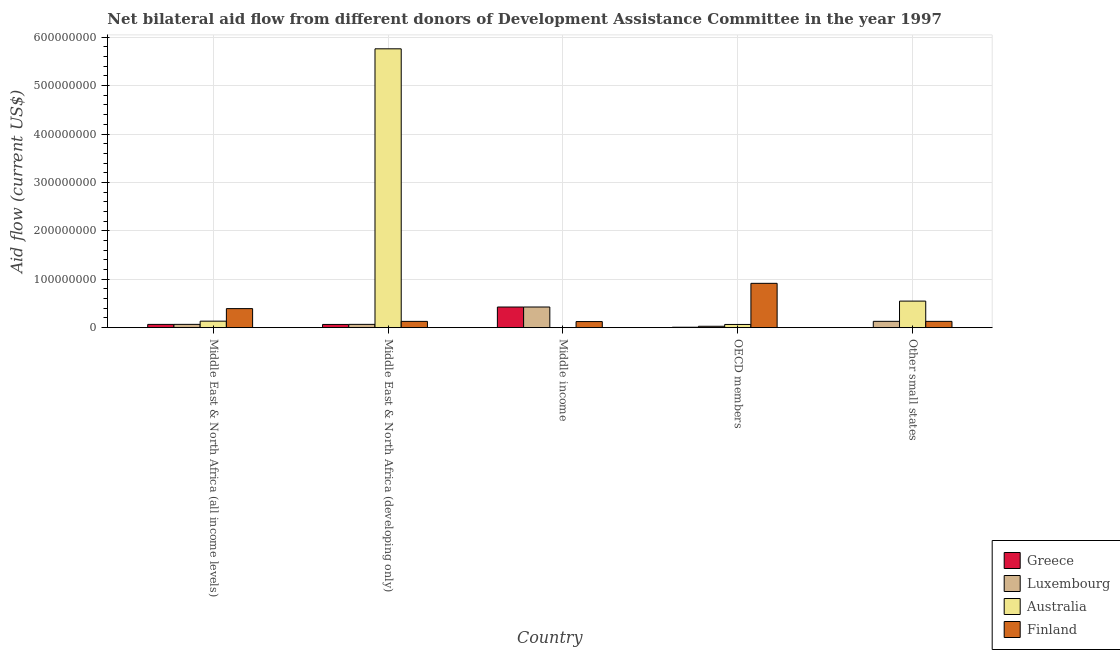How many different coloured bars are there?
Provide a succinct answer. 4. Are the number of bars per tick equal to the number of legend labels?
Keep it short and to the point. Yes. Are the number of bars on each tick of the X-axis equal?
Keep it short and to the point. Yes. How many bars are there on the 4th tick from the right?
Offer a terse response. 4. What is the label of the 5th group of bars from the left?
Your answer should be very brief. Other small states. What is the amount of aid given by finland in Other small states?
Make the answer very short. 1.30e+07. Across all countries, what is the maximum amount of aid given by greece?
Keep it short and to the point. 4.26e+07. Across all countries, what is the minimum amount of aid given by luxembourg?
Offer a terse response. 2.88e+06. In which country was the amount of aid given by finland maximum?
Make the answer very short. OECD members. In which country was the amount of aid given by luxembourg minimum?
Your answer should be compact. OECD members. What is the total amount of aid given by luxembourg in the graph?
Make the answer very short. 7.22e+07. What is the difference between the amount of aid given by australia in OECD members and that in Other small states?
Offer a very short reply. -4.82e+07. What is the difference between the amount of aid given by australia in OECD members and the amount of aid given by luxembourg in Middle East & North Africa (all income levels)?
Make the answer very short. -1.80e+05. What is the average amount of aid given by greece per country?
Your answer should be very brief. 1.14e+07. What is the difference between the amount of aid given by luxembourg and amount of aid given by greece in Other small states?
Provide a succinct answer. 1.30e+07. What is the ratio of the amount of aid given by finland in OECD members to that in Other small states?
Your answer should be very brief. 7.04. Is the amount of aid given by australia in Middle East & North Africa (developing only) less than that in OECD members?
Your answer should be very brief. No. What is the difference between the highest and the second highest amount of aid given by australia?
Your answer should be compact. 5.21e+08. What is the difference between the highest and the lowest amount of aid given by finland?
Give a very brief answer. 7.90e+07. Is the sum of the amount of aid given by greece in Middle East & North Africa (all income levels) and Other small states greater than the maximum amount of aid given by australia across all countries?
Provide a succinct answer. No. What does the 1st bar from the right in Middle East & North Africa (developing only) represents?
Provide a succinct answer. Finland. How many bars are there?
Give a very brief answer. 20. How many countries are there in the graph?
Provide a short and direct response. 5. What is the difference between two consecutive major ticks on the Y-axis?
Your response must be concise. 1.00e+08. Are the values on the major ticks of Y-axis written in scientific E-notation?
Provide a short and direct response. No. Does the graph contain any zero values?
Provide a succinct answer. No. Does the graph contain grids?
Provide a short and direct response. Yes. How many legend labels are there?
Offer a terse response. 4. How are the legend labels stacked?
Provide a short and direct response. Vertical. What is the title of the graph?
Your answer should be very brief. Net bilateral aid flow from different donors of Development Assistance Committee in the year 1997. Does "Fiscal policy" appear as one of the legend labels in the graph?
Your answer should be very brief. No. What is the Aid flow (current US$) in Greece in Middle East & North Africa (all income levels)?
Your answer should be compact. 6.76e+06. What is the Aid flow (current US$) of Luxembourg in Middle East & North Africa (all income levels)?
Your response must be concise. 6.80e+06. What is the Aid flow (current US$) in Australia in Middle East & North Africa (all income levels)?
Provide a short and direct response. 1.34e+07. What is the Aid flow (current US$) in Finland in Middle East & North Africa (all income levels)?
Provide a short and direct response. 3.94e+07. What is the Aid flow (current US$) of Greece in Middle East & North Africa (developing only)?
Ensure brevity in your answer.  6.66e+06. What is the Aid flow (current US$) in Luxembourg in Middle East & North Africa (developing only)?
Keep it short and to the point. 6.80e+06. What is the Aid flow (current US$) in Australia in Middle East & North Africa (developing only)?
Offer a terse response. 5.76e+08. What is the Aid flow (current US$) in Finland in Middle East & North Africa (developing only)?
Your answer should be compact. 1.30e+07. What is the Aid flow (current US$) in Greece in Middle income?
Offer a very short reply. 4.26e+07. What is the Aid flow (current US$) in Luxembourg in Middle income?
Your answer should be compact. 4.27e+07. What is the Aid flow (current US$) in Australia in Middle income?
Your answer should be compact. 2.40e+05. What is the Aid flow (current US$) of Finland in Middle income?
Your answer should be compact. 1.26e+07. What is the Aid flow (current US$) in Luxembourg in OECD members?
Ensure brevity in your answer.  2.88e+06. What is the Aid flow (current US$) of Australia in OECD members?
Offer a terse response. 6.62e+06. What is the Aid flow (current US$) of Finland in OECD members?
Offer a very short reply. 9.16e+07. What is the Aid flow (current US$) in Greece in Other small states?
Offer a terse response. 1.10e+05. What is the Aid flow (current US$) of Luxembourg in Other small states?
Provide a succinct answer. 1.31e+07. What is the Aid flow (current US$) in Australia in Other small states?
Provide a succinct answer. 5.49e+07. What is the Aid flow (current US$) of Finland in Other small states?
Make the answer very short. 1.30e+07. Across all countries, what is the maximum Aid flow (current US$) in Greece?
Keep it short and to the point. 4.26e+07. Across all countries, what is the maximum Aid flow (current US$) in Luxembourg?
Ensure brevity in your answer.  4.27e+07. Across all countries, what is the maximum Aid flow (current US$) of Australia?
Provide a short and direct response. 5.76e+08. Across all countries, what is the maximum Aid flow (current US$) in Finland?
Offer a terse response. 9.16e+07. Across all countries, what is the minimum Aid flow (current US$) of Greece?
Give a very brief answer. 1.10e+05. Across all countries, what is the minimum Aid flow (current US$) in Luxembourg?
Provide a short and direct response. 2.88e+06. Across all countries, what is the minimum Aid flow (current US$) in Australia?
Your answer should be very brief. 2.40e+05. Across all countries, what is the minimum Aid flow (current US$) in Finland?
Your answer should be compact. 1.26e+07. What is the total Aid flow (current US$) of Greece in the graph?
Give a very brief answer. 5.71e+07. What is the total Aid flow (current US$) of Luxembourg in the graph?
Ensure brevity in your answer.  7.22e+07. What is the total Aid flow (current US$) in Australia in the graph?
Make the answer very short. 6.51e+08. What is the total Aid flow (current US$) in Finland in the graph?
Keep it short and to the point. 1.69e+08. What is the difference between the Aid flow (current US$) of Luxembourg in Middle East & North Africa (all income levels) and that in Middle East & North Africa (developing only)?
Your answer should be compact. 0. What is the difference between the Aid flow (current US$) of Australia in Middle East & North Africa (all income levels) and that in Middle East & North Africa (developing only)?
Provide a succinct answer. -5.63e+08. What is the difference between the Aid flow (current US$) of Finland in Middle East & North Africa (all income levels) and that in Middle East & North Africa (developing only)?
Provide a short and direct response. 2.64e+07. What is the difference between the Aid flow (current US$) in Greece in Middle East & North Africa (all income levels) and that in Middle income?
Offer a terse response. -3.59e+07. What is the difference between the Aid flow (current US$) in Luxembourg in Middle East & North Africa (all income levels) and that in Middle income?
Your answer should be very brief. -3.59e+07. What is the difference between the Aid flow (current US$) in Australia in Middle East & North Africa (all income levels) and that in Middle income?
Give a very brief answer. 1.32e+07. What is the difference between the Aid flow (current US$) in Finland in Middle East & North Africa (all income levels) and that in Middle income?
Offer a very short reply. 2.68e+07. What is the difference between the Aid flow (current US$) in Greece in Middle East & North Africa (all income levels) and that in OECD members?
Provide a short and direct response. 5.86e+06. What is the difference between the Aid flow (current US$) of Luxembourg in Middle East & North Africa (all income levels) and that in OECD members?
Make the answer very short. 3.92e+06. What is the difference between the Aid flow (current US$) in Australia in Middle East & North Africa (all income levels) and that in OECD members?
Make the answer very short. 6.80e+06. What is the difference between the Aid flow (current US$) of Finland in Middle East & North Africa (all income levels) and that in OECD members?
Ensure brevity in your answer.  -5.22e+07. What is the difference between the Aid flow (current US$) in Greece in Middle East & North Africa (all income levels) and that in Other small states?
Your response must be concise. 6.65e+06. What is the difference between the Aid flow (current US$) of Luxembourg in Middle East & North Africa (all income levels) and that in Other small states?
Ensure brevity in your answer.  -6.26e+06. What is the difference between the Aid flow (current US$) in Australia in Middle East & North Africa (all income levels) and that in Other small states?
Offer a very short reply. -4.14e+07. What is the difference between the Aid flow (current US$) of Finland in Middle East & North Africa (all income levels) and that in Other small states?
Your response must be concise. 2.64e+07. What is the difference between the Aid flow (current US$) in Greece in Middle East & North Africa (developing only) and that in Middle income?
Make the answer very short. -3.60e+07. What is the difference between the Aid flow (current US$) in Luxembourg in Middle East & North Africa (developing only) and that in Middle income?
Provide a succinct answer. -3.59e+07. What is the difference between the Aid flow (current US$) of Australia in Middle East & North Africa (developing only) and that in Middle income?
Make the answer very short. 5.76e+08. What is the difference between the Aid flow (current US$) in Greece in Middle East & North Africa (developing only) and that in OECD members?
Offer a very short reply. 5.76e+06. What is the difference between the Aid flow (current US$) of Luxembourg in Middle East & North Africa (developing only) and that in OECD members?
Offer a very short reply. 3.92e+06. What is the difference between the Aid flow (current US$) in Australia in Middle East & North Africa (developing only) and that in OECD members?
Provide a succinct answer. 5.69e+08. What is the difference between the Aid flow (current US$) in Finland in Middle East & North Africa (developing only) and that in OECD members?
Your response must be concise. -7.86e+07. What is the difference between the Aid flow (current US$) of Greece in Middle East & North Africa (developing only) and that in Other small states?
Make the answer very short. 6.55e+06. What is the difference between the Aid flow (current US$) in Luxembourg in Middle East & North Africa (developing only) and that in Other small states?
Offer a terse response. -6.26e+06. What is the difference between the Aid flow (current US$) in Australia in Middle East & North Africa (developing only) and that in Other small states?
Your answer should be compact. 5.21e+08. What is the difference between the Aid flow (current US$) of Finland in Middle East & North Africa (developing only) and that in Other small states?
Your answer should be very brief. -3.00e+04. What is the difference between the Aid flow (current US$) in Greece in Middle income and that in OECD members?
Provide a short and direct response. 4.17e+07. What is the difference between the Aid flow (current US$) of Luxembourg in Middle income and that in OECD members?
Offer a terse response. 3.98e+07. What is the difference between the Aid flow (current US$) in Australia in Middle income and that in OECD members?
Provide a succinct answer. -6.38e+06. What is the difference between the Aid flow (current US$) in Finland in Middle income and that in OECD members?
Provide a short and direct response. -7.90e+07. What is the difference between the Aid flow (current US$) in Greece in Middle income and that in Other small states?
Give a very brief answer. 4.25e+07. What is the difference between the Aid flow (current US$) of Luxembourg in Middle income and that in Other small states?
Offer a terse response. 2.96e+07. What is the difference between the Aid flow (current US$) of Australia in Middle income and that in Other small states?
Give a very brief answer. -5.46e+07. What is the difference between the Aid flow (current US$) of Finland in Middle income and that in Other small states?
Provide a succinct answer. -4.20e+05. What is the difference between the Aid flow (current US$) in Greece in OECD members and that in Other small states?
Keep it short and to the point. 7.90e+05. What is the difference between the Aid flow (current US$) in Luxembourg in OECD members and that in Other small states?
Offer a terse response. -1.02e+07. What is the difference between the Aid flow (current US$) of Australia in OECD members and that in Other small states?
Your response must be concise. -4.82e+07. What is the difference between the Aid flow (current US$) in Finland in OECD members and that in Other small states?
Your answer should be very brief. 7.86e+07. What is the difference between the Aid flow (current US$) of Greece in Middle East & North Africa (all income levels) and the Aid flow (current US$) of Luxembourg in Middle East & North Africa (developing only)?
Offer a terse response. -4.00e+04. What is the difference between the Aid flow (current US$) in Greece in Middle East & North Africa (all income levels) and the Aid flow (current US$) in Australia in Middle East & North Africa (developing only)?
Your answer should be very brief. -5.69e+08. What is the difference between the Aid flow (current US$) of Greece in Middle East & North Africa (all income levels) and the Aid flow (current US$) of Finland in Middle East & North Africa (developing only)?
Make the answer very short. -6.21e+06. What is the difference between the Aid flow (current US$) of Luxembourg in Middle East & North Africa (all income levels) and the Aid flow (current US$) of Australia in Middle East & North Africa (developing only)?
Provide a short and direct response. -5.69e+08. What is the difference between the Aid flow (current US$) of Luxembourg in Middle East & North Africa (all income levels) and the Aid flow (current US$) of Finland in Middle East & North Africa (developing only)?
Your answer should be compact. -6.17e+06. What is the difference between the Aid flow (current US$) of Greece in Middle East & North Africa (all income levels) and the Aid flow (current US$) of Luxembourg in Middle income?
Provide a succinct answer. -3.59e+07. What is the difference between the Aid flow (current US$) in Greece in Middle East & North Africa (all income levels) and the Aid flow (current US$) in Australia in Middle income?
Offer a terse response. 6.52e+06. What is the difference between the Aid flow (current US$) in Greece in Middle East & North Africa (all income levels) and the Aid flow (current US$) in Finland in Middle income?
Your answer should be very brief. -5.82e+06. What is the difference between the Aid flow (current US$) in Luxembourg in Middle East & North Africa (all income levels) and the Aid flow (current US$) in Australia in Middle income?
Offer a terse response. 6.56e+06. What is the difference between the Aid flow (current US$) of Luxembourg in Middle East & North Africa (all income levels) and the Aid flow (current US$) of Finland in Middle income?
Offer a very short reply. -5.78e+06. What is the difference between the Aid flow (current US$) in Australia in Middle East & North Africa (all income levels) and the Aid flow (current US$) in Finland in Middle income?
Provide a short and direct response. 8.40e+05. What is the difference between the Aid flow (current US$) of Greece in Middle East & North Africa (all income levels) and the Aid flow (current US$) of Luxembourg in OECD members?
Give a very brief answer. 3.88e+06. What is the difference between the Aid flow (current US$) in Greece in Middle East & North Africa (all income levels) and the Aid flow (current US$) in Finland in OECD members?
Offer a very short reply. -8.48e+07. What is the difference between the Aid flow (current US$) of Luxembourg in Middle East & North Africa (all income levels) and the Aid flow (current US$) of Australia in OECD members?
Make the answer very short. 1.80e+05. What is the difference between the Aid flow (current US$) in Luxembourg in Middle East & North Africa (all income levels) and the Aid flow (current US$) in Finland in OECD members?
Provide a succinct answer. -8.48e+07. What is the difference between the Aid flow (current US$) of Australia in Middle East & North Africa (all income levels) and the Aid flow (current US$) of Finland in OECD members?
Ensure brevity in your answer.  -7.82e+07. What is the difference between the Aid flow (current US$) in Greece in Middle East & North Africa (all income levels) and the Aid flow (current US$) in Luxembourg in Other small states?
Your answer should be compact. -6.30e+06. What is the difference between the Aid flow (current US$) in Greece in Middle East & North Africa (all income levels) and the Aid flow (current US$) in Australia in Other small states?
Keep it short and to the point. -4.81e+07. What is the difference between the Aid flow (current US$) of Greece in Middle East & North Africa (all income levels) and the Aid flow (current US$) of Finland in Other small states?
Your answer should be very brief. -6.24e+06. What is the difference between the Aid flow (current US$) of Luxembourg in Middle East & North Africa (all income levels) and the Aid flow (current US$) of Australia in Other small states?
Ensure brevity in your answer.  -4.81e+07. What is the difference between the Aid flow (current US$) in Luxembourg in Middle East & North Africa (all income levels) and the Aid flow (current US$) in Finland in Other small states?
Offer a very short reply. -6.20e+06. What is the difference between the Aid flow (current US$) of Greece in Middle East & North Africa (developing only) and the Aid flow (current US$) of Luxembourg in Middle income?
Provide a succinct answer. -3.60e+07. What is the difference between the Aid flow (current US$) of Greece in Middle East & North Africa (developing only) and the Aid flow (current US$) of Australia in Middle income?
Offer a very short reply. 6.42e+06. What is the difference between the Aid flow (current US$) of Greece in Middle East & North Africa (developing only) and the Aid flow (current US$) of Finland in Middle income?
Provide a succinct answer. -5.92e+06. What is the difference between the Aid flow (current US$) in Luxembourg in Middle East & North Africa (developing only) and the Aid flow (current US$) in Australia in Middle income?
Keep it short and to the point. 6.56e+06. What is the difference between the Aid flow (current US$) of Luxembourg in Middle East & North Africa (developing only) and the Aid flow (current US$) of Finland in Middle income?
Ensure brevity in your answer.  -5.78e+06. What is the difference between the Aid flow (current US$) of Australia in Middle East & North Africa (developing only) and the Aid flow (current US$) of Finland in Middle income?
Provide a succinct answer. 5.63e+08. What is the difference between the Aid flow (current US$) in Greece in Middle East & North Africa (developing only) and the Aid flow (current US$) in Luxembourg in OECD members?
Provide a short and direct response. 3.78e+06. What is the difference between the Aid flow (current US$) of Greece in Middle East & North Africa (developing only) and the Aid flow (current US$) of Australia in OECD members?
Offer a terse response. 4.00e+04. What is the difference between the Aid flow (current US$) in Greece in Middle East & North Africa (developing only) and the Aid flow (current US$) in Finland in OECD members?
Offer a very short reply. -8.49e+07. What is the difference between the Aid flow (current US$) of Luxembourg in Middle East & North Africa (developing only) and the Aid flow (current US$) of Australia in OECD members?
Offer a very short reply. 1.80e+05. What is the difference between the Aid flow (current US$) in Luxembourg in Middle East & North Africa (developing only) and the Aid flow (current US$) in Finland in OECD members?
Ensure brevity in your answer.  -8.48e+07. What is the difference between the Aid flow (current US$) of Australia in Middle East & North Africa (developing only) and the Aid flow (current US$) of Finland in OECD members?
Your response must be concise. 4.84e+08. What is the difference between the Aid flow (current US$) in Greece in Middle East & North Africa (developing only) and the Aid flow (current US$) in Luxembourg in Other small states?
Provide a short and direct response. -6.40e+06. What is the difference between the Aid flow (current US$) in Greece in Middle East & North Africa (developing only) and the Aid flow (current US$) in Australia in Other small states?
Your answer should be very brief. -4.82e+07. What is the difference between the Aid flow (current US$) of Greece in Middle East & North Africa (developing only) and the Aid flow (current US$) of Finland in Other small states?
Provide a succinct answer. -6.34e+06. What is the difference between the Aid flow (current US$) in Luxembourg in Middle East & North Africa (developing only) and the Aid flow (current US$) in Australia in Other small states?
Your answer should be very brief. -4.81e+07. What is the difference between the Aid flow (current US$) of Luxembourg in Middle East & North Africa (developing only) and the Aid flow (current US$) of Finland in Other small states?
Your answer should be compact. -6.20e+06. What is the difference between the Aid flow (current US$) of Australia in Middle East & North Africa (developing only) and the Aid flow (current US$) of Finland in Other small states?
Provide a short and direct response. 5.63e+08. What is the difference between the Aid flow (current US$) in Greece in Middle income and the Aid flow (current US$) in Luxembourg in OECD members?
Keep it short and to the point. 3.98e+07. What is the difference between the Aid flow (current US$) in Greece in Middle income and the Aid flow (current US$) in Australia in OECD members?
Provide a short and direct response. 3.60e+07. What is the difference between the Aid flow (current US$) in Greece in Middle income and the Aid flow (current US$) in Finland in OECD members?
Keep it short and to the point. -4.89e+07. What is the difference between the Aid flow (current US$) in Luxembourg in Middle income and the Aid flow (current US$) in Australia in OECD members?
Offer a very short reply. 3.60e+07. What is the difference between the Aid flow (current US$) of Luxembourg in Middle income and the Aid flow (current US$) of Finland in OECD members?
Provide a succinct answer. -4.89e+07. What is the difference between the Aid flow (current US$) in Australia in Middle income and the Aid flow (current US$) in Finland in OECD members?
Give a very brief answer. -9.13e+07. What is the difference between the Aid flow (current US$) of Greece in Middle income and the Aid flow (current US$) of Luxembourg in Other small states?
Provide a succinct answer. 2.96e+07. What is the difference between the Aid flow (current US$) of Greece in Middle income and the Aid flow (current US$) of Australia in Other small states?
Ensure brevity in your answer.  -1.22e+07. What is the difference between the Aid flow (current US$) in Greece in Middle income and the Aid flow (current US$) in Finland in Other small states?
Keep it short and to the point. 2.96e+07. What is the difference between the Aid flow (current US$) of Luxembourg in Middle income and the Aid flow (current US$) of Australia in Other small states?
Your answer should be compact. -1.22e+07. What is the difference between the Aid flow (current US$) of Luxembourg in Middle income and the Aid flow (current US$) of Finland in Other small states?
Provide a succinct answer. 2.97e+07. What is the difference between the Aid flow (current US$) in Australia in Middle income and the Aid flow (current US$) in Finland in Other small states?
Keep it short and to the point. -1.28e+07. What is the difference between the Aid flow (current US$) in Greece in OECD members and the Aid flow (current US$) in Luxembourg in Other small states?
Your answer should be very brief. -1.22e+07. What is the difference between the Aid flow (current US$) in Greece in OECD members and the Aid flow (current US$) in Australia in Other small states?
Offer a very short reply. -5.40e+07. What is the difference between the Aid flow (current US$) of Greece in OECD members and the Aid flow (current US$) of Finland in Other small states?
Offer a terse response. -1.21e+07. What is the difference between the Aid flow (current US$) in Luxembourg in OECD members and the Aid flow (current US$) in Australia in Other small states?
Offer a very short reply. -5.20e+07. What is the difference between the Aid flow (current US$) in Luxembourg in OECD members and the Aid flow (current US$) in Finland in Other small states?
Offer a terse response. -1.01e+07. What is the difference between the Aid flow (current US$) of Australia in OECD members and the Aid flow (current US$) of Finland in Other small states?
Your answer should be very brief. -6.38e+06. What is the average Aid flow (current US$) in Greece per country?
Your response must be concise. 1.14e+07. What is the average Aid flow (current US$) of Luxembourg per country?
Offer a very short reply. 1.44e+07. What is the average Aid flow (current US$) in Australia per country?
Keep it short and to the point. 1.30e+08. What is the average Aid flow (current US$) in Finland per country?
Provide a short and direct response. 3.39e+07. What is the difference between the Aid flow (current US$) in Greece and Aid flow (current US$) in Australia in Middle East & North Africa (all income levels)?
Give a very brief answer. -6.66e+06. What is the difference between the Aid flow (current US$) in Greece and Aid flow (current US$) in Finland in Middle East & North Africa (all income levels)?
Offer a terse response. -3.26e+07. What is the difference between the Aid flow (current US$) of Luxembourg and Aid flow (current US$) of Australia in Middle East & North Africa (all income levels)?
Keep it short and to the point. -6.62e+06. What is the difference between the Aid flow (current US$) of Luxembourg and Aid flow (current US$) of Finland in Middle East & North Africa (all income levels)?
Give a very brief answer. -3.26e+07. What is the difference between the Aid flow (current US$) in Australia and Aid flow (current US$) in Finland in Middle East & North Africa (all income levels)?
Give a very brief answer. -2.59e+07. What is the difference between the Aid flow (current US$) of Greece and Aid flow (current US$) of Australia in Middle East & North Africa (developing only)?
Offer a very short reply. -5.69e+08. What is the difference between the Aid flow (current US$) in Greece and Aid flow (current US$) in Finland in Middle East & North Africa (developing only)?
Your answer should be compact. -6.31e+06. What is the difference between the Aid flow (current US$) in Luxembourg and Aid flow (current US$) in Australia in Middle East & North Africa (developing only)?
Provide a short and direct response. -5.69e+08. What is the difference between the Aid flow (current US$) of Luxembourg and Aid flow (current US$) of Finland in Middle East & North Africa (developing only)?
Ensure brevity in your answer.  -6.17e+06. What is the difference between the Aid flow (current US$) of Australia and Aid flow (current US$) of Finland in Middle East & North Africa (developing only)?
Your answer should be very brief. 5.63e+08. What is the difference between the Aid flow (current US$) of Greece and Aid flow (current US$) of Australia in Middle income?
Your response must be concise. 4.24e+07. What is the difference between the Aid flow (current US$) in Greece and Aid flow (current US$) in Finland in Middle income?
Give a very brief answer. 3.01e+07. What is the difference between the Aid flow (current US$) of Luxembourg and Aid flow (current US$) of Australia in Middle income?
Your answer should be compact. 4.24e+07. What is the difference between the Aid flow (current US$) in Luxembourg and Aid flow (current US$) in Finland in Middle income?
Offer a very short reply. 3.01e+07. What is the difference between the Aid flow (current US$) in Australia and Aid flow (current US$) in Finland in Middle income?
Provide a succinct answer. -1.23e+07. What is the difference between the Aid flow (current US$) of Greece and Aid flow (current US$) of Luxembourg in OECD members?
Provide a short and direct response. -1.98e+06. What is the difference between the Aid flow (current US$) in Greece and Aid flow (current US$) in Australia in OECD members?
Provide a short and direct response. -5.72e+06. What is the difference between the Aid flow (current US$) of Greece and Aid flow (current US$) of Finland in OECD members?
Make the answer very short. -9.07e+07. What is the difference between the Aid flow (current US$) of Luxembourg and Aid flow (current US$) of Australia in OECD members?
Keep it short and to the point. -3.74e+06. What is the difference between the Aid flow (current US$) of Luxembourg and Aid flow (current US$) of Finland in OECD members?
Offer a terse response. -8.87e+07. What is the difference between the Aid flow (current US$) of Australia and Aid flow (current US$) of Finland in OECD members?
Offer a terse response. -8.50e+07. What is the difference between the Aid flow (current US$) in Greece and Aid flow (current US$) in Luxembourg in Other small states?
Your answer should be very brief. -1.30e+07. What is the difference between the Aid flow (current US$) in Greece and Aid flow (current US$) in Australia in Other small states?
Keep it short and to the point. -5.48e+07. What is the difference between the Aid flow (current US$) in Greece and Aid flow (current US$) in Finland in Other small states?
Provide a succinct answer. -1.29e+07. What is the difference between the Aid flow (current US$) in Luxembourg and Aid flow (current US$) in Australia in Other small states?
Give a very brief answer. -4.18e+07. What is the difference between the Aid flow (current US$) of Australia and Aid flow (current US$) of Finland in Other small states?
Provide a succinct answer. 4.19e+07. What is the ratio of the Aid flow (current US$) in Greece in Middle East & North Africa (all income levels) to that in Middle East & North Africa (developing only)?
Ensure brevity in your answer.  1.01. What is the ratio of the Aid flow (current US$) in Luxembourg in Middle East & North Africa (all income levels) to that in Middle East & North Africa (developing only)?
Provide a succinct answer. 1. What is the ratio of the Aid flow (current US$) in Australia in Middle East & North Africa (all income levels) to that in Middle East & North Africa (developing only)?
Your answer should be very brief. 0.02. What is the ratio of the Aid flow (current US$) in Finland in Middle East & North Africa (all income levels) to that in Middle East & North Africa (developing only)?
Make the answer very short. 3.03. What is the ratio of the Aid flow (current US$) of Greece in Middle East & North Africa (all income levels) to that in Middle income?
Offer a terse response. 0.16. What is the ratio of the Aid flow (current US$) in Luxembourg in Middle East & North Africa (all income levels) to that in Middle income?
Your response must be concise. 0.16. What is the ratio of the Aid flow (current US$) in Australia in Middle East & North Africa (all income levels) to that in Middle income?
Your answer should be compact. 55.92. What is the ratio of the Aid flow (current US$) of Finland in Middle East & North Africa (all income levels) to that in Middle income?
Ensure brevity in your answer.  3.13. What is the ratio of the Aid flow (current US$) in Greece in Middle East & North Africa (all income levels) to that in OECD members?
Your answer should be very brief. 7.51. What is the ratio of the Aid flow (current US$) in Luxembourg in Middle East & North Africa (all income levels) to that in OECD members?
Ensure brevity in your answer.  2.36. What is the ratio of the Aid flow (current US$) in Australia in Middle East & North Africa (all income levels) to that in OECD members?
Provide a succinct answer. 2.03. What is the ratio of the Aid flow (current US$) of Finland in Middle East & North Africa (all income levels) to that in OECD members?
Offer a very short reply. 0.43. What is the ratio of the Aid flow (current US$) in Greece in Middle East & North Africa (all income levels) to that in Other small states?
Ensure brevity in your answer.  61.45. What is the ratio of the Aid flow (current US$) in Luxembourg in Middle East & North Africa (all income levels) to that in Other small states?
Make the answer very short. 0.52. What is the ratio of the Aid flow (current US$) of Australia in Middle East & North Africa (all income levels) to that in Other small states?
Keep it short and to the point. 0.24. What is the ratio of the Aid flow (current US$) of Finland in Middle East & North Africa (all income levels) to that in Other small states?
Provide a short and direct response. 3.03. What is the ratio of the Aid flow (current US$) of Greece in Middle East & North Africa (developing only) to that in Middle income?
Keep it short and to the point. 0.16. What is the ratio of the Aid flow (current US$) in Luxembourg in Middle East & North Africa (developing only) to that in Middle income?
Provide a short and direct response. 0.16. What is the ratio of the Aid flow (current US$) in Australia in Middle East & North Africa (developing only) to that in Middle income?
Your answer should be very brief. 2400.25. What is the ratio of the Aid flow (current US$) of Finland in Middle East & North Africa (developing only) to that in Middle income?
Offer a terse response. 1.03. What is the ratio of the Aid flow (current US$) of Greece in Middle East & North Africa (developing only) to that in OECD members?
Keep it short and to the point. 7.4. What is the ratio of the Aid flow (current US$) in Luxembourg in Middle East & North Africa (developing only) to that in OECD members?
Your answer should be very brief. 2.36. What is the ratio of the Aid flow (current US$) in Australia in Middle East & North Africa (developing only) to that in OECD members?
Provide a short and direct response. 87.02. What is the ratio of the Aid flow (current US$) of Finland in Middle East & North Africa (developing only) to that in OECD members?
Your answer should be very brief. 0.14. What is the ratio of the Aid flow (current US$) in Greece in Middle East & North Africa (developing only) to that in Other small states?
Provide a short and direct response. 60.55. What is the ratio of the Aid flow (current US$) in Luxembourg in Middle East & North Africa (developing only) to that in Other small states?
Provide a short and direct response. 0.52. What is the ratio of the Aid flow (current US$) in Australia in Middle East & North Africa (developing only) to that in Other small states?
Keep it short and to the point. 10.5. What is the ratio of the Aid flow (current US$) in Greece in Middle income to that in OECD members?
Keep it short and to the point. 47.38. What is the ratio of the Aid flow (current US$) of Luxembourg in Middle income to that in OECD members?
Give a very brief answer. 14.81. What is the ratio of the Aid flow (current US$) of Australia in Middle income to that in OECD members?
Offer a very short reply. 0.04. What is the ratio of the Aid flow (current US$) in Finland in Middle income to that in OECD members?
Keep it short and to the point. 0.14. What is the ratio of the Aid flow (current US$) in Greece in Middle income to that in Other small states?
Give a very brief answer. 387.64. What is the ratio of the Aid flow (current US$) in Luxembourg in Middle income to that in Other small states?
Your answer should be compact. 3.27. What is the ratio of the Aid flow (current US$) in Australia in Middle income to that in Other small states?
Your response must be concise. 0. What is the ratio of the Aid flow (current US$) of Greece in OECD members to that in Other small states?
Provide a short and direct response. 8.18. What is the ratio of the Aid flow (current US$) of Luxembourg in OECD members to that in Other small states?
Ensure brevity in your answer.  0.22. What is the ratio of the Aid flow (current US$) in Australia in OECD members to that in Other small states?
Provide a succinct answer. 0.12. What is the ratio of the Aid flow (current US$) in Finland in OECD members to that in Other small states?
Provide a short and direct response. 7.04. What is the difference between the highest and the second highest Aid flow (current US$) in Greece?
Offer a terse response. 3.59e+07. What is the difference between the highest and the second highest Aid flow (current US$) in Luxembourg?
Keep it short and to the point. 2.96e+07. What is the difference between the highest and the second highest Aid flow (current US$) of Australia?
Make the answer very short. 5.21e+08. What is the difference between the highest and the second highest Aid flow (current US$) in Finland?
Offer a very short reply. 5.22e+07. What is the difference between the highest and the lowest Aid flow (current US$) of Greece?
Provide a short and direct response. 4.25e+07. What is the difference between the highest and the lowest Aid flow (current US$) in Luxembourg?
Give a very brief answer. 3.98e+07. What is the difference between the highest and the lowest Aid flow (current US$) in Australia?
Keep it short and to the point. 5.76e+08. What is the difference between the highest and the lowest Aid flow (current US$) in Finland?
Your response must be concise. 7.90e+07. 